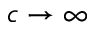Convert formula to latex. <formula><loc_0><loc_0><loc_500><loc_500>c \rightarrow \infty</formula> 